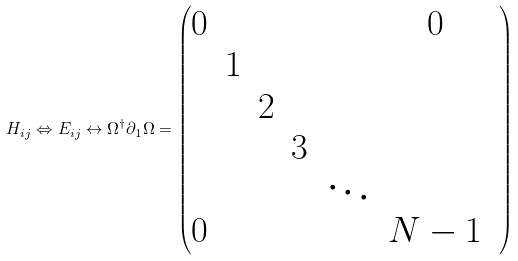<formula> <loc_0><loc_0><loc_500><loc_500>H _ { i j } \Leftrightarrow E _ { i j } \leftrightarrow { \Omega ^ { \dag } } { \partial _ { 1 } } \Omega = \begin{pmatrix} 0 & & & & & 0 \\ & 1 & & & & & \\ & & 2 & & & & \\ & & & 3 & & & \\ & & & & \ddots & \\ 0 & & & & & N - 1 \\ \end{pmatrix}</formula> 